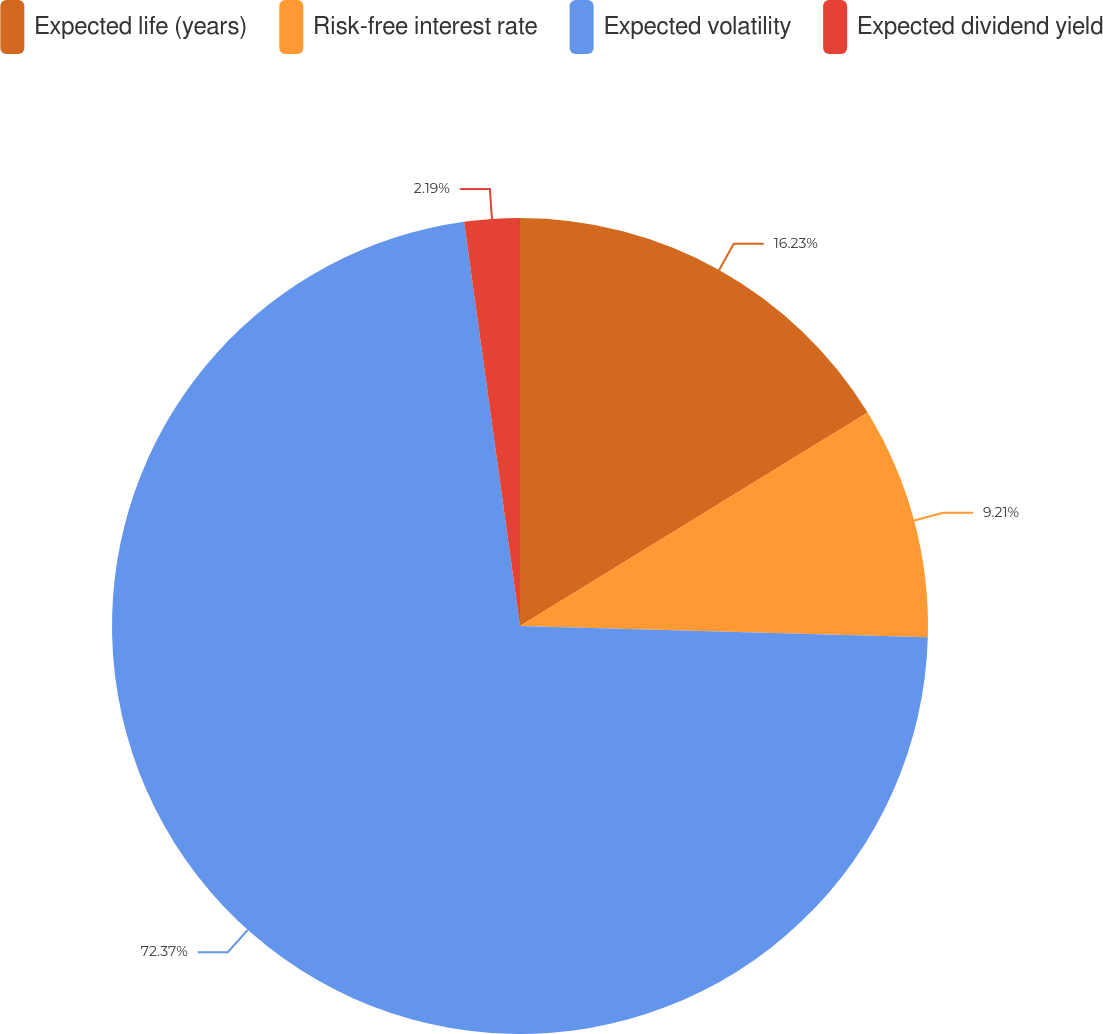Convert chart to OTSL. <chart><loc_0><loc_0><loc_500><loc_500><pie_chart><fcel>Expected life (years)<fcel>Risk-free interest rate<fcel>Expected volatility<fcel>Expected dividend yield<nl><fcel>16.23%<fcel>9.21%<fcel>72.37%<fcel>2.19%<nl></chart> 